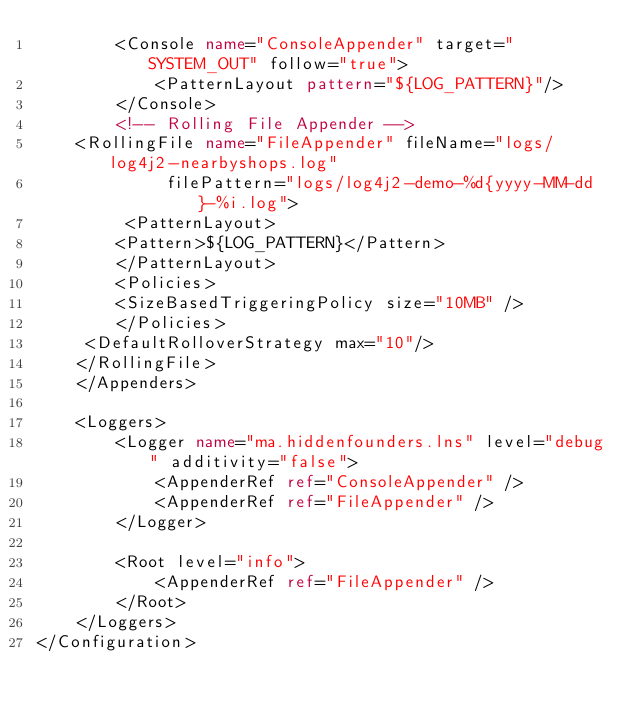<code> <loc_0><loc_0><loc_500><loc_500><_XML_>        <Console name="ConsoleAppender" target="SYSTEM_OUT" follow="true">
            <PatternLayout pattern="${LOG_PATTERN}"/>
        </Console>
        <!-- Rolling File Appender -->
	<RollingFile name="FileAppender" fileName="logs/log4j2-nearbyshops.log" 
             filePattern="logs/log4j2-demo-%d{yyyy-MM-dd}-%i.log">
   		 <PatternLayout>
        <Pattern>${LOG_PATTERN}</Pattern>
    	</PatternLayout>
    	<Policies>
        <SizeBasedTriggeringPolicy size="10MB" />
    	</Policies>
   	 <DefaultRolloverStrategy max="10"/>
	</RollingFile>
    </Appenders>
    
    <Loggers>
        <Logger name="ma.hiddenfounders.lns" level="debug" additivity="false">
            <AppenderRef ref="ConsoleAppender" />
            <AppenderRef ref="FileAppender" />
        </Logger>

        <Root level="info">
            <AppenderRef ref="FileAppender" />
        </Root>
    </Loggers>
</Configuration></code> 